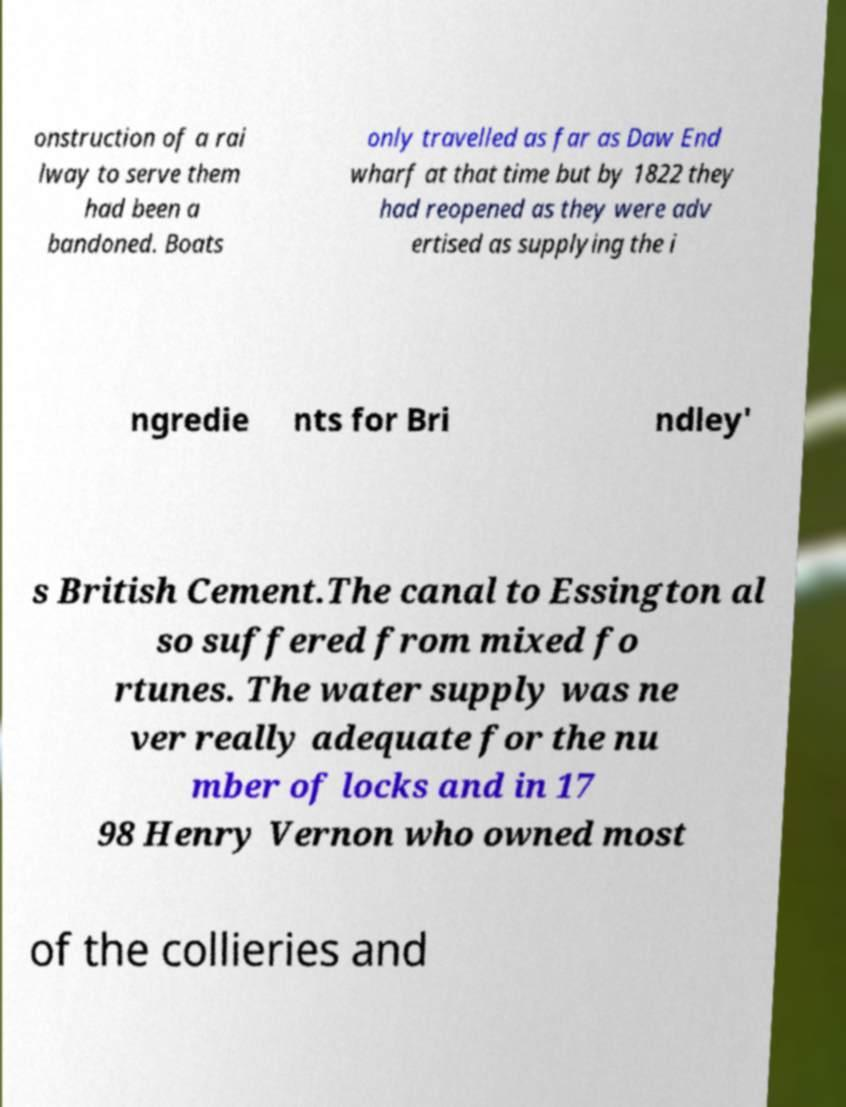Can you accurately transcribe the text from the provided image for me? onstruction of a rai lway to serve them had been a bandoned. Boats only travelled as far as Daw End wharf at that time but by 1822 they had reopened as they were adv ertised as supplying the i ngredie nts for Bri ndley' s British Cement.The canal to Essington al so suffered from mixed fo rtunes. The water supply was ne ver really adequate for the nu mber of locks and in 17 98 Henry Vernon who owned most of the collieries and 